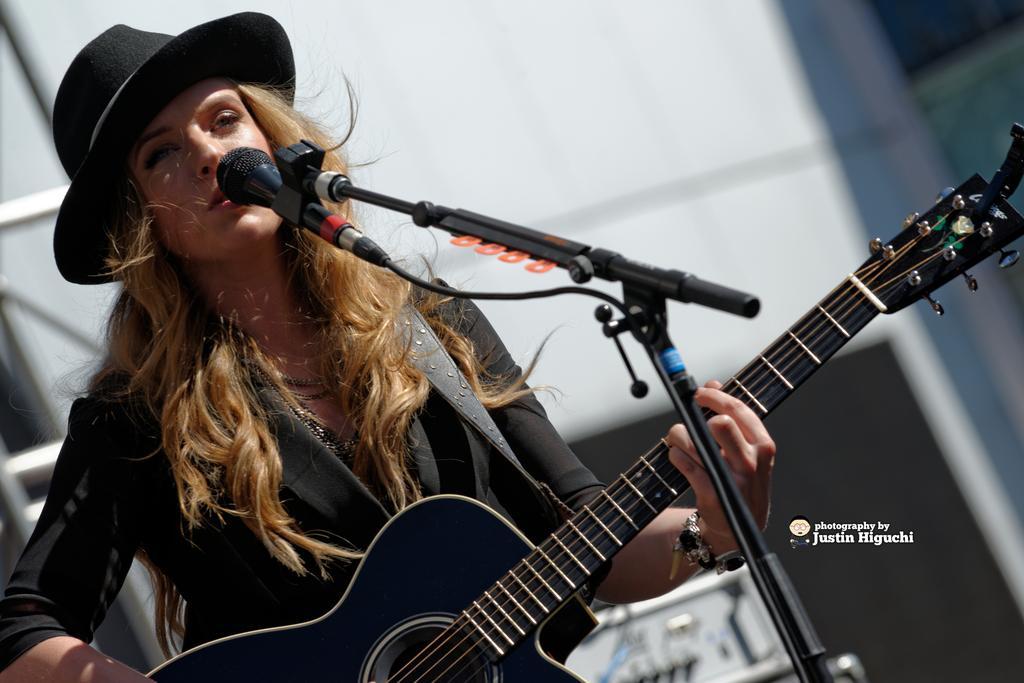Could you give a brief overview of what you see in this image? The woman with blond hair wearing a black jacket and a black hat holding a guitar singing on a mic which was held to a stand. 